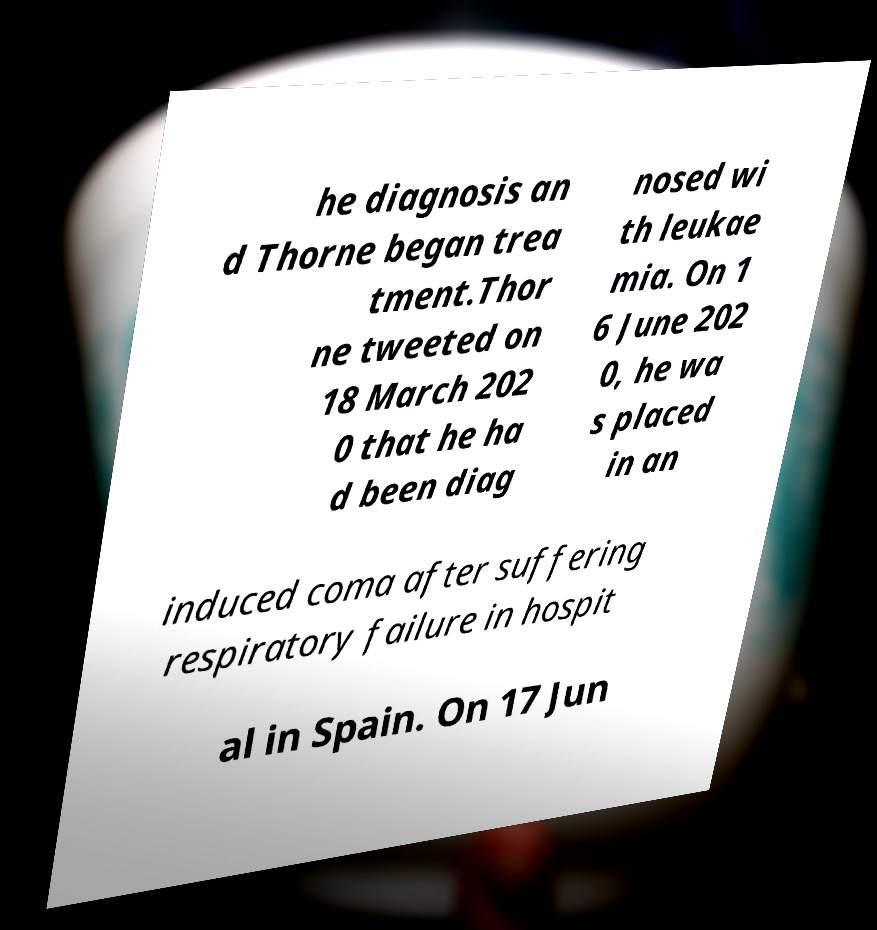Could you assist in decoding the text presented in this image and type it out clearly? he diagnosis an d Thorne began trea tment.Thor ne tweeted on 18 March 202 0 that he ha d been diag nosed wi th leukae mia. On 1 6 June 202 0, he wa s placed in an induced coma after suffering respiratory failure in hospit al in Spain. On 17 Jun 